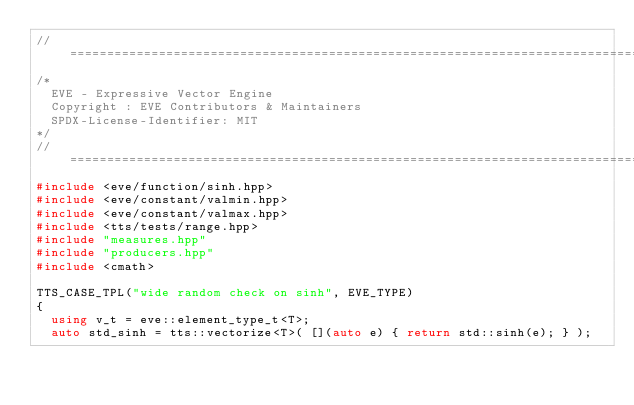<code> <loc_0><loc_0><loc_500><loc_500><_C++_>//==================================================================================================
/*
  EVE - Expressive Vector Engine
  Copyright : EVE Contributors & Maintainers
  SPDX-License-Identifier: MIT
*/
//==================================================================================================
#include <eve/function/sinh.hpp>
#include <eve/constant/valmin.hpp>
#include <eve/constant/valmax.hpp>
#include <tts/tests/range.hpp>
#include "measures.hpp"
#include "producers.hpp"
#include <cmath>

TTS_CASE_TPL("wide random check on sinh", EVE_TYPE)
{
  using v_t = eve::element_type_t<T>;
  auto std_sinh = tts::vectorize<T>( [](auto e) { return std::sinh(e); } );
</code> 